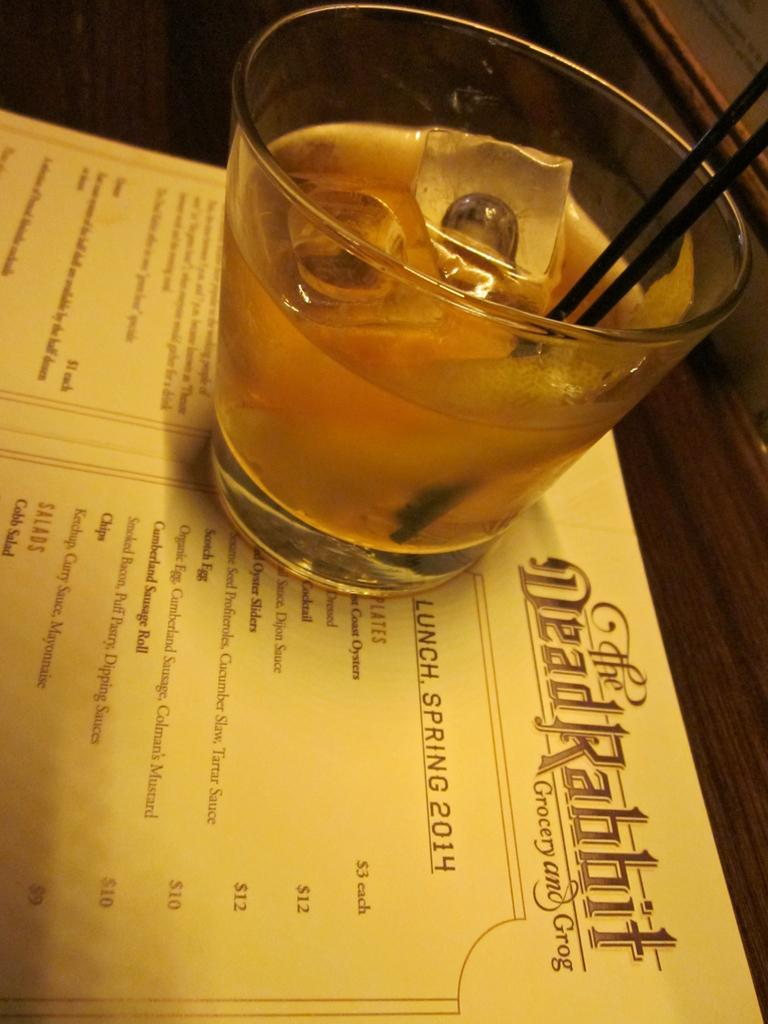Provide a one-sentence caption for the provided image. A menu from The Dead Rabbit is open and has a drink sitting on top of it. 